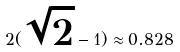Convert formula to latex. <formula><loc_0><loc_0><loc_500><loc_500>2 ( \sqrt { 2 } - 1 ) \approx 0 . 8 2 8</formula> 